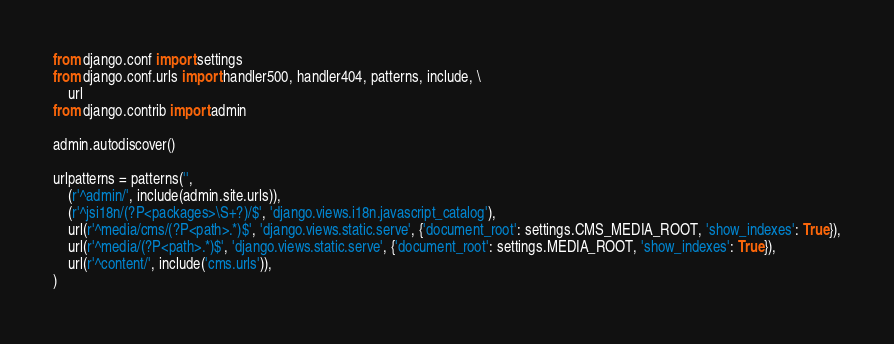Convert code to text. <code><loc_0><loc_0><loc_500><loc_500><_Python_>from django.conf import settings
from django.conf.urls import handler500, handler404, patterns, include, \
    url
from django.contrib import admin

admin.autodiscover()

urlpatterns = patterns('',
    (r'^admin/', include(admin.site.urls)),
    (r'^jsi18n/(?P<packages>\S+?)/$', 'django.views.i18n.javascript_catalog'),
    url(r'^media/cms/(?P<path>.*)$', 'django.views.static.serve', {'document_root': settings.CMS_MEDIA_ROOT, 'show_indexes': True}),
    url(r'^media/(?P<path>.*)$', 'django.views.static.serve', {'document_root': settings.MEDIA_ROOT, 'show_indexes': True}),
    url(r'^content/', include('cms.urls')),
)
</code> 